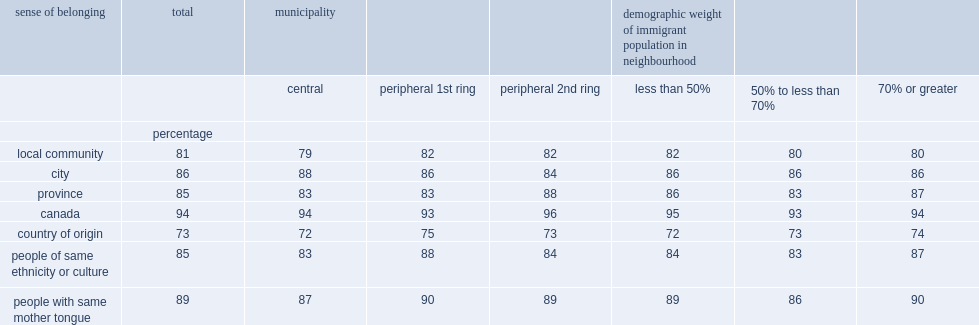What is share of the population with an immigrant background that expressed strong sense of belonging to canada? 94.0. What is share of the population with an immigrant background that expressed strong sense of belonging to the province? 85.0. What is share of the population with an immigrant background that expressed strong sense of belonging to the town or city? 86.0. What is the proportion of respondents who expreseed strong sense of belonging to the local community? 81.0. What is the percentage of the population with an immigrant background that reported a somewhat strong or very strong sense of belonging with people who have the same mother tongue? 89.0. What is the percentage of the population that reported a sense of belonging for attachment to people of the same ethnicity or culture? 85.0. What is the percentage of the population that reported a sense of belonging to their country of origin? 73.0. 